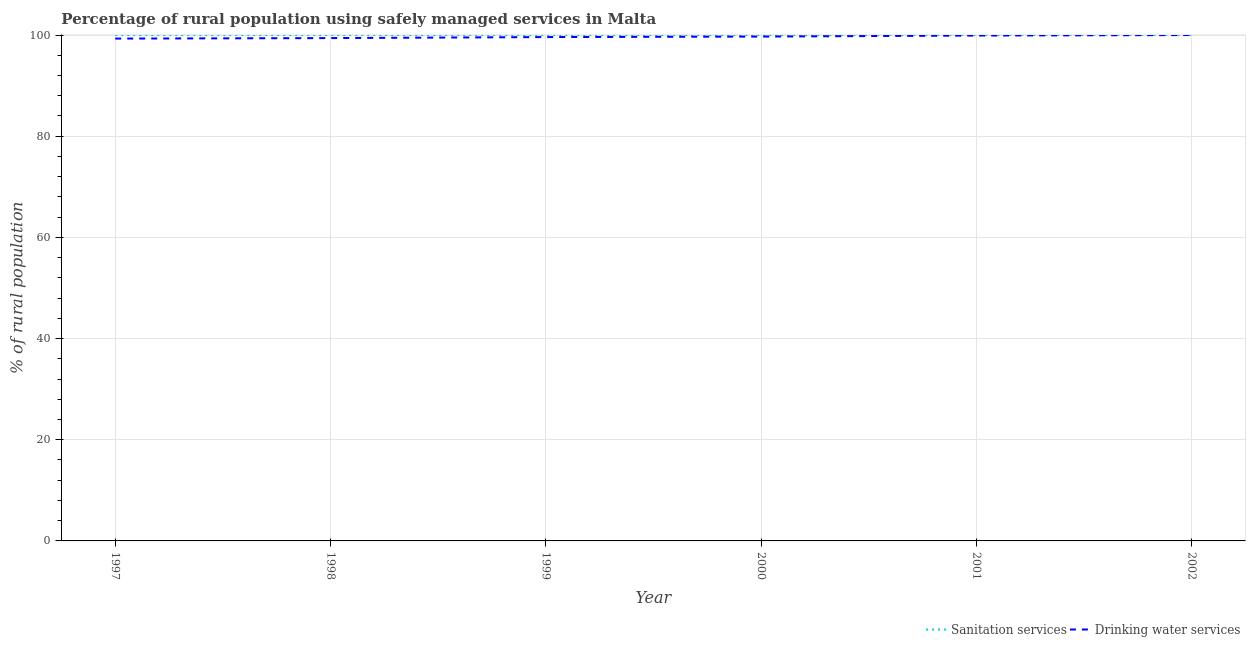How many different coloured lines are there?
Your answer should be very brief. 2. Is the number of lines equal to the number of legend labels?
Give a very brief answer. Yes. What is the percentage of rural population who used sanitation services in 1998?
Offer a terse response. 100. Across all years, what is the maximum percentage of rural population who used sanitation services?
Provide a short and direct response. 100. Across all years, what is the minimum percentage of rural population who used drinking water services?
Provide a succinct answer. 99.3. In which year was the percentage of rural population who used drinking water services maximum?
Keep it short and to the point. 2002. What is the total percentage of rural population who used sanitation services in the graph?
Offer a terse response. 600. What is the difference between the percentage of rural population who used drinking water services in 1998 and that in 1999?
Your response must be concise. -0.2. What is the difference between the percentage of rural population who used drinking water services in 1999 and the percentage of rural population who used sanitation services in 2001?
Give a very brief answer. -0.4. In the year 2001, what is the difference between the percentage of rural population who used sanitation services and percentage of rural population who used drinking water services?
Make the answer very short. 0.1. In how many years, is the percentage of rural population who used drinking water services greater than 36 %?
Offer a very short reply. 6. Is the percentage of rural population who used drinking water services in 1997 less than that in 1998?
Offer a very short reply. Yes. Is the difference between the percentage of rural population who used sanitation services in 1997 and 1998 greater than the difference between the percentage of rural population who used drinking water services in 1997 and 1998?
Offer a very short reply. Yes. What is the difference between the highest and the second highest percentage of rural population who used drinking water services?
Offer a terse response. 0.1. Is the sum of the percentage of rural population who used sanitation services in 2000 and 2002 greater than the maximum percentage of rural population who used drinking water services across all years?
Offer a very short reply. Yes. Does the percentage of rural population who used sanitation services monotonically increase over the years?
Offer a very short reply. No. Is the percentage of rural population who used sanitation services strictly greater than the percentage of rural population who used drinking water services over the years?
Make the answer very short. No. How many lines are there?
Make the answer very short. 2. What is the difference between two consecutive major ticks on the Y-axis?
Provide a short and direct response. 20. Does the graph contain any zero values?
Make the answer very short. No. Does the graph contain grids?
Offer a very short reply. Yes. Where does the legend appear in the graph?
Offer a terse response. Bottom right. How are the legend labels stacked?
Offer a terse response. Horizontal. What is the title of the graph?
Make the answer very short. Percentage of rural population using safely managed services in Malta. Does "current US$" appear as one of the legend labels in the graph?
Your response must be concise. No. What is the label or title of the Y-axis?
Offer a very short reply. % of rural population. What is the % of rural population of Drinking water services in 1997?
Offer a terse response. 99.3. What is the % of rural population of Drinking water services in 1998?
Give a very brief answer. 99.4. What is the % of rural population in Sanitation services in 1999?
Offer a terse response. 100. What is the % of rural population in Drinking water services in 1999?
Your answer should be compact. 99.6. What is the % of rural population of Drinking water services in 2000?
Keep it short and to the point. 99.7. What is the % of rural population in Sanitation services in 2001?
Your answer should be compact. 100. What is the % of rural population in Drinking water services in 2001?
Provide a short and direct response. 99.9. What is the % of rural population in Sanitation services in 2002?
Keep it short and to the point. 100. What is the % of rural population of Drinking water services in 2002?
Ensure brevity in your answer.  100. Across all years, what is the minimum % of rural population of Sanitation services?
Your answer should be compact. 100. Across all years, what is the minimum % of rural population of Drinking water services?
Make the answer very short. 99.3. What is the total % of rural population in Sanitation services in the graph?
Offer a terse response. 600. What is the total % of rural population of Drinking water services in the graph?
Provide a succinct answer. 597.9. What is the difference between the % of rural population in Drinking water services in 1997 and that in 1999?
Your answer should be very brief. -0.3. What is the difference between the % of rural population of Sanitation services in 1997 and that in 2000?
Offer a terse response. 0. What is the difference between the % of rural population of Sanitation services in 1997 and that in 2001?
Your response must be concise. 0. What is the difference between the % of rural population in Sanitation services in 1998 and that in 1999?
Your response must be concise. 0. What is the difference between the % of rural population in Drinking water services in 1998 and that in 1999?
Provide a succinct answer. -0.2. What is the difference between the % of rural population in Drinking water services in 1999 and that in 2000?
Give a very brief answer. -0.1. What is the difference between the % of rural population in Drinking water services in 1999 and that in 2001?
Your response must be concise. -0.3. What is the difference between the % of rural population of Sanitation services in 1999 and that in 2002?
Make the answer very short. 0. What is the difference between the % of rural population of Sanitation services in 2000 and that in 2001?
Give a very brief answer. 0. What is the difference between the % of rural population of Drinking water services in 2001 and that in 2002?
Your answer should be compact. -0.1. What is the difference between the % of rural population in Sanitation services in 1997 and the % of rural population in Drinking water services in 1998?
Offer a very short reply. 0.6. What is the difference between the % of rural population in Sanitation services in 1997 and the % of rural population in Drinking water services in 1999?
Ensure brevity in your answer.  0.4. What is the difference between the % of rural population in Sanitation services in 1997 and the % of rural population in Drinking water services in 2001?
Offer a terse response. 0.1. What is the difference between the % of rural population in Sanitation services in 1997 and the % of rural population in Drinking water services in 2002?
Ensure brevity in your answer.  0. What is the difference between the % of rural population of Sanitation services in 1998 and the % of rural population of Drinking water services in 1999?
Make the answer very short. 0.4. What is the difference between the % of rural population of Sanitation services in 1998 and the % of rural population of Drinking water services in 2002?
Ensure brevity in your answer.  0. What is the difference between the % of rural population of Sanitation services in 2000 and the % of rural population of Drinking water services in 2001?
Keep it short and to the point. 0.1. What is the difference between the % of rural population of Sanitation services in 2000 and the % of rural population of Drinking water services in 2002?
Make the answer very short. 0. What is the difference between the % of rural population of Sanitation services in 2001 and the % of rural population of Drinking water services in 2002?
Keep it short and to the point. 0. What is the average % of rural population in Drinking water services per year?
Provide a succinct answer. 99.65. In the year 1997, what is the difference between the % of rural population in Sanitation services and % of rural population in Drinking water services?
Ensure brevity in your answer.  0.7. In the year 1998, what is the difference between the % of rural population in Sanitation services and % of rural population in Drinking water services?
Provide a short and direct response. 0.6. In the year 1999, what is the difference between the % of rural population in Sanitation services and % of rural population in Drinking water services?
Provide a short and direct response. 0.4. What is the ratio of the % of rural population of Sanitation services in 1997 to that in 1998?
Your answer should be compact. 1. What is the ratio of the % of rural population of Drinking water services in 1997 to that in 2001?
Ensure brevity in your answer.  0.99. What is the ratio of the % of rural population in Sanitation services in 1998 to that in 1999?
Make the answer very short. 1. What is the ratio of the % of rural population in Drinking water services in 1998 to that in 1999?
Give a very brief answer. 1. What is the ratio of the % of rural population in Drinking water services in 1998 to that in 2000?
Give a very brief answer. 1. What is the ratio of the % of rural population of Sanitation services in 1998 to that in 2001?
Offer a terse response. 1. What is the ratio of the % of rural population in Drinking water services in 1999 to that in 2000?
Your answer should be very brief. 1. What is the ratio of the % of rural population in Drinking water services in 1999 to that in 2001?
Make the answer very short. 1. What is the ratio of the % of rural population in Drinking water services in 1999 to that in 2002?
Ensure brevity in your answer.  1. What is the ratio of the % of rural population in Drinking water services in 2000 to that in 2001?
Make the answer very short. 1. What is the ratio of the % of rural population in Drinking water services in 2000 to that in 2002?
Your answer should be very brief. 1. What is the ratio of the % of rural population in Sanitation services in 2001 to that in 2002?
Your answer should be compact. 1. What is the difference between the highest and the second highest % of rural population in Sanitation services?
Make the answer very short. 0. What is the difference between the highest and the second highest % of rural population of Drinking water services?
Your response must be concise. 0.1. 